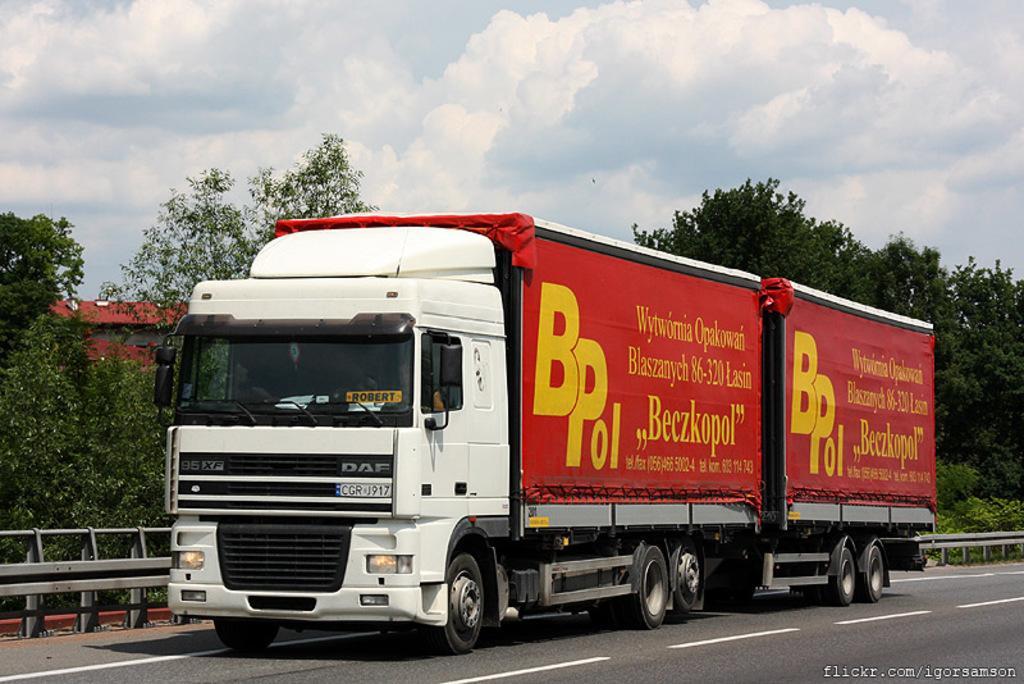How would you summarize this image in a sentence or two? In the background we can see the sky with clouds, trees. We can see a vehicle on the road near to the railing. At the bottom portion of the picture we can see the water mark. 